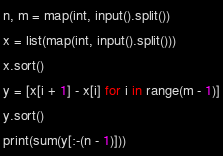Convert code to text. <code><loc_0><loc_0><loc_500><loc_500><_Python_>n, m = map(int, input().split())
x = list(map(int, input().split()))
x.sort()
y = [x[i + 1] - x[i] for i in range(m - 1)]
y.sort()
print(sum(y[:-(n - 1)]))
</code> 